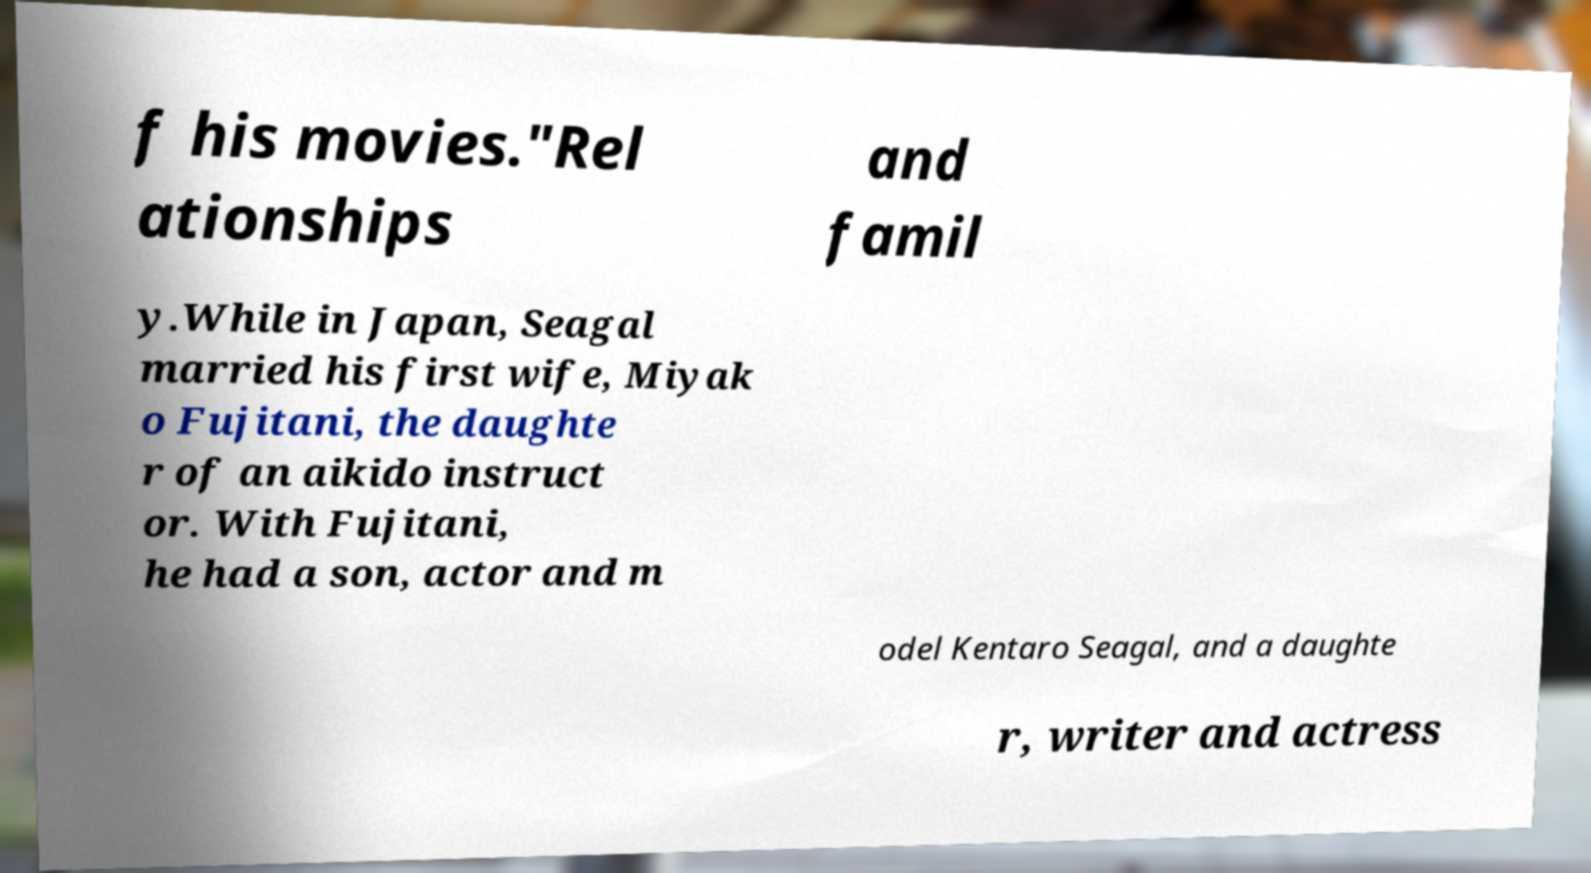Can you read and provide the text displayed in the image?This photo seems to have some interesting text. Can you extract and type it out for me? f his movies."Rel ationships and famil y.While in Japan, Seagal married his first wife, Miyak o Fujitani, the daughte r of an aikido instruct or. With Fujitani, he had a son, actor and m odel Kentaro Seagal, and a daughte r, writer and actress 